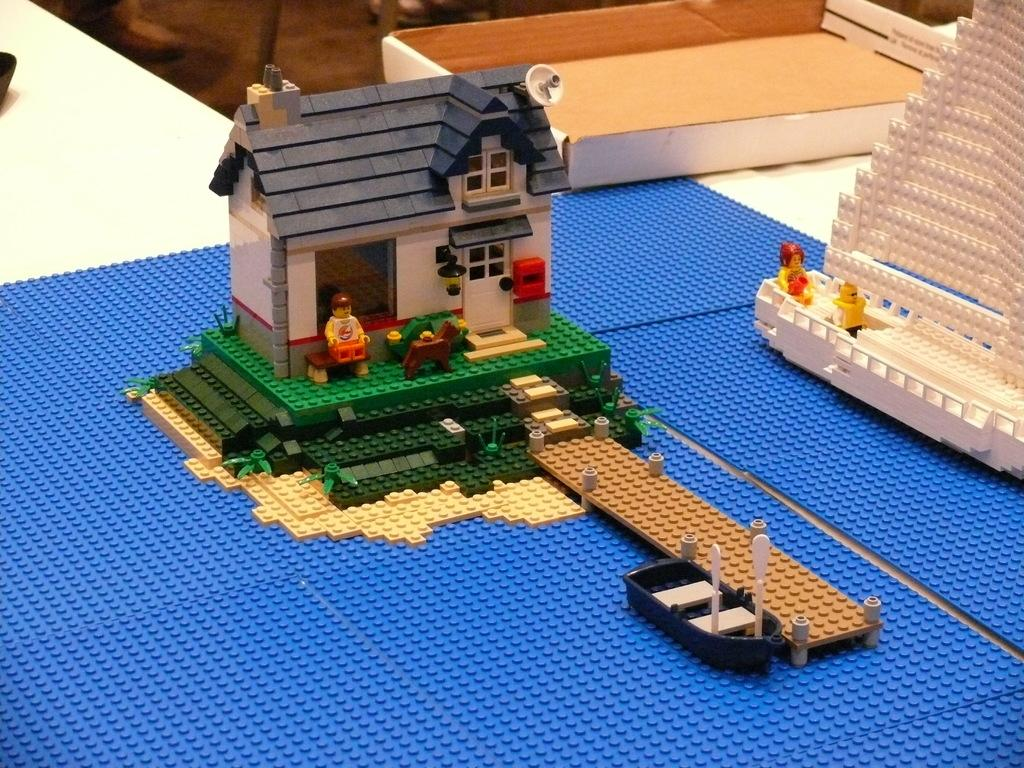What type of object is in the image? There is a toy in the image. What material is the toy made from? The toy is made from building blocks. Where is the toy located in the image? The toy is on a table. What type of weather condition is present in the image? There is no weather condition mentioned in the image; it only features a toy made from building blocks on a table. 